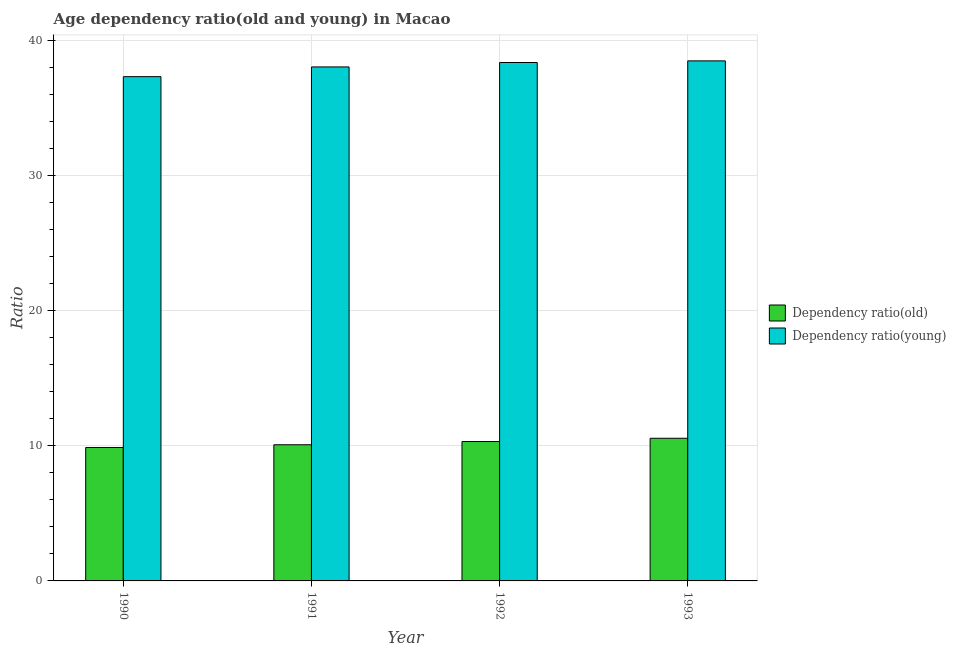How many different coloured bars are there?
Your response must be concise. 2. How many groups of bars are there?
Your answer should be very brief. 4. In how many cases, is the number of bars for a given year not equal to the number of legend labels?
Offer a terse response. 0. What is the age dependency ratio(old) in 1993?
Your response must be concise. 10.56. Across all years, what is the maximum age dependency ratio(old)?
Provide a succinct answer. 10.56. Across all years, what is the minimum age dependency ratio(young)?
Provide a succinct answer. 37.32. In which year was the age dependency ratio(young) maximum?
Offer a terse response. 1993. What is the total age dependency ratio(old) in the graph?
Your answer should be very brief. 40.83. What is the difference between the age dependency ratio(young) in 1991 and that in 1993?
Offer a terse response. -0.45. What is the difference between the age dependency ratio(old) in 1992 and the age dependency ratio(young) in 1991?
Give a very brief answer. 0.24. What is the average age dependency ratio(old) per year?
Your response must be concise. 10.21. In the year 1990, what is the difference between the age dependency ratio(young) and age dependency ratio(old)?
Your answer should be compact. 0. What is the ratio of the age dependency ratio(old) in 1991 to that in 1992?
Keep it short and to the point. 0.98. Is the age dependency ratio(young) in 1990 less than that in 1993?
Keep it short and to the point. Yes. What is the difference between the highest and the second highest age dependency ratio(young)?
Ensure brevity in your answer.  0.12. What is the difference between the highest and the lowest age dependency ratio(old)?
Provide a short and direct response. 0.68. Is the sum of the age dependency ratio(old) in 1992 and 1993 greater than the maximum age dependency ratio(young) across all years?
Keep it short and to the point. Yes. What does the 2nd bar from the left in 1990 represents?
Provide a succinct answer. Dependency ratio(young). What does the 1st bar from the right in 1993 represents?
Your answer should be very brief. Dependency ratio(young). Are all the bars in the graph horizontal?
Your answer should be compact. No. Does the graph contain grids?
Offer a very short reply. Yes. Where does the legend appear in the graph?
Your answer should be compact. Center right. How many legend labels are there?
Provide a succinct answer. 2. How are the legend labels stacked?
Give a very brief answer. Vertical. What is the title of the graph?
Provide a succinct answer. Age dependency ratio(old and young) in Macao. Does "Netherlands" appear as one of the legend labels in the graph?
Offer a very short reply. No. What is the label or title of the X-axis?
Your answer should be compact. Year. What is the label or title of the Y-axis?
Your answer should be very brief. Ratio. What is the Ratio of Dependency ratio(old) in 1990?
Offer a very short reply. 9.88. What is the Ratio of Dependency ratio(young) in 1990?
Provide a succinct answer. 37.32. What is the Ratio in Dependency ratio(old) in 1991?
Your answer should be very brief. 10.08. What is the Ratio of Dependency ratio(young) in 1991?
Your response must be concise. 38.04. What is the Ratio in Dependency ratio(old) in 1992?
Keep it short and to the point. 10.32. What is the Ratio in Dependency ratio(young) in 1992?
Provide a succinct answer. 38.37. What is the Ratio in Dependency ratio(old) in 1993?
Provide a succinct answer. 10.56. What is the Ratio in Dependency ratio(young) in 1993?
Your response must be concise. 38.49. Across all years, what is the maximum Ratio of Dependency ratio(old)?
Your answer should be compact. 10.56. Across all years, what is the maximum Ratio in Dependency ratio(young)?
Offer a very short reply. 38.49. Across all years, what is the minimum Ratio in Dependency ratio(old)?
Ensure brevity in your answer.  9.88. Across all years, what is the minimum Ratio in Dependency ratio(young)?
Offer a very short reply. 37.32. What is the total Ratio in Dependency ratio(old) in the graph?
Offer a very short reply. 40.83. What is the total Ratio of Dependency ratio(young) in the graph?
Ensure brevity in your answer.  152.23. What is the difference between the Ratio in Dependency ratio(old) in 1990 and that in 1991?
Provide a short and direct response. -0.2. What is the difference between the Ratio of Dependency ratio(young) in 1990 and that in 1991?
Your answer should be very brief. -0.72. What is the difference between the Ratio in Dependency ratio(old) in 1990 and that in 1992?
Your response must be concise. -0.44. What is the difference between the Ratio of Dependency ratio(young) in 1990 and that in 1992?
Provide a short and direct response. -1.05. What is the difference between the Ratio of Dependency ratio(old) in 1990 and that in 1993?
Offer a very short reply. -0.68. What is the difference between the Ratio in Dependency ratio(young) in 1990 and that in 1993?
Provide a succinct answer. -1.17. What is the difference between the Ratio of Dependency ratio(old) in 1991 and that in 1992?
Ensure brevity in your answer.  -0.24. What is the difference between the Ratio of Dependency ratio(young) in 1991 and that in 1992?
Your answer should be very brief. -0.33. What is the difference between the Ratio in Dependency ratio(old) in 1991 and that in 1993?
Your response must be concise. -0.48. What is the difference between the Ratio in Dependency ratio(young) in 1991 and that in 1993?
Provide a succinct answer. -0.45. What is the difference between the Ratio of Dependency ratio(old) in 1992 and that in 1993?
Ensure brevity in your answer.  -0.24. What is the difference between the Ratio of Dependency ratio(young) in 1992 and that in 1993?
Provide a short and direct response. -0.12. What is the difference between the Ratio of Dependency ratio(old) in 1990 and the Ratio of Dependency ratio(young) in 1991?
Give a very brief answer. -28.17. What is the difference between the Ratio of Dependency ratio(old) in 1990 and the Ratio of Dependency ratio(young) in 1992?
Provide a short and direct response. -28.5. What is the difference between the Ratio of Dependency ratio(old) in 1990 and the Ratio of Dependency ratio(young) in 1993?
Offer a very short reply. -28.62. What is the difference between the Ratio of Dependency ratio(old) in 1991 and the Ratio of Dependency ratio(young) in 1992?
Your answer should be very brief. -28.29. What is the difference between the Ratio in Dependency ratio(old) in 1991 and the Ratio in Dependency ratio(young) in 1993?
Ensure brevity in your answer.  -28.41. What is the difference between the Ratio in Dependency ratio(old) in 1992 and the Ratio in Dependency ratio(young) in 1993?
Make the answer very short. -28.17. What is the average Ratio in Dependency ratio(old) per year?
Your answer should be compact. 10.21. What is the average Ratio of Dependency ratio(young) per year?
Provide a short and direct response. 38.06. In the year 1990, what is the difference between the Ratio of Dependency ratio(old) and Ratio of Dependency ratio(young)?
Make the answer very short. -27.45. In the year 1991, what is the difference between the Ratio in Dependency ratio(old) and Ratio in Dependency ratio(young)?
Keep it short and to the point. -27.97. In the year 1992, what is the difference between the Ratio in Dependency ratio(old) and Ratio in Dependency ratio(young)?
Make the answer very short. -28.05. In the year 1993, what is the difference between the Ratio in Dependency ratio(old) and Ratio in Dependency ratio(young)?
Your answer should be compact. -27.93. What is the ratio of the Ratio of Dependency ratio(old) in 1990 to that in 1991?
Your response must be concise. 0.98. What is the ratio of the Ratio of Dependency ratio(young) in 1990 to that in 1991?
Your response must be concise. 0.98. What is the ratio of the Ratio in Dependency ratio(old) in 1990 to that in 1992?
Your response must be concise. 0.96. What is the ratio of the Ratio of Dependency ratio(young) in 1990 to that in 1992?
Offer a very short reply. 0.97. What is the ratio of the Ratio of Dependency ratio(old) in 1990 to that in 1993?
Give a very brief answer. 0.94. What is the ratio of the Ratio in Dependency ratio(young) in 1990 to that in 1993?
Provide a short and direct response. 0.97. What is the ratio of the Ratio of Dependency ratio(old) in 1991 to that in 1992?
Keep it short and to the point. 0.98. What is the ratio of the Ratio in Dependency ratio(young) in 1991 to that in 1992?
Make the answer very short. 0.99. What is the ratio of the Ratio in Dependency ratio(old) in 1991 to that in 1993?
Offer a very short reply. 0.95. What is the ratio of the Ratio of Dependency ratio(young) in 1991 to that in 1993?
Offer a very short reply. 0.99. What is the ratio of the Ratio in Dependency ratio(old) in 1992 to that in 1993?
Ensure brevity in your answer.  0.98. What is the ratio of the Ratio in Dependency ratio(young) in 1992 to that in 1993?
Make the answer very short. 1. What is the difference between the highest and the second highest Ratio of Dependency ratio(old)?
Offer a terse response. 0.24. What is the difference between the highest and the second highest Ratio in Dependency ratio(young)?
Your response must be concise. 0.12. What is the difference between the highest and the lowest Ratio of Dependency ratio(old)?
Your answer should be compact. 0.68. What is the difference between the highest and the lowest Ratio in Dependency ratio(young)?
Offer a very short reply. 1.17. 